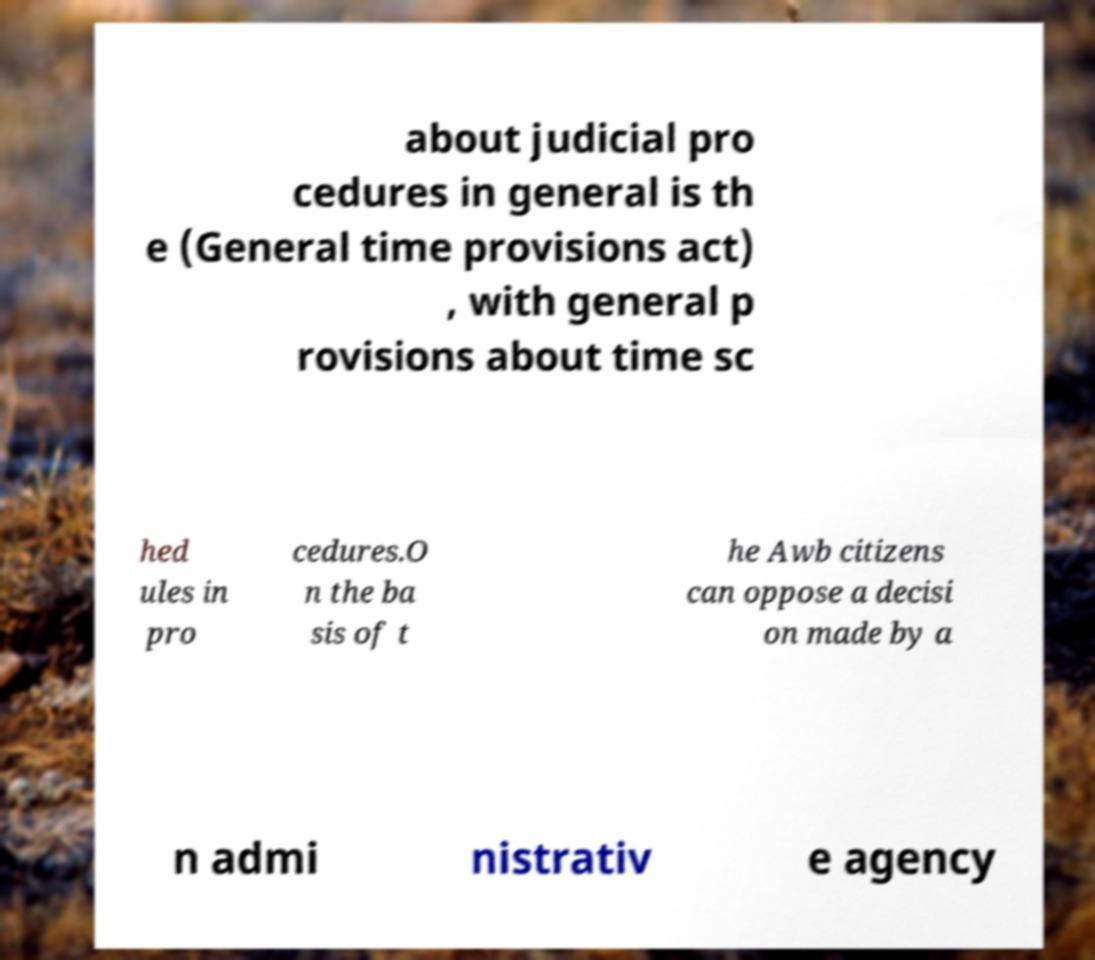There's text embedded in this image that I need extracted. Can you transcribe it verbatim? about judicial pro cedures in general is th e (General time provisions act) , with general p rovisions about time sc hed ules in pro cedures.O n the ba sis of t he Awb citizens can oppose a decisi on made by a n admi nistrativ e agency 